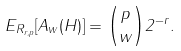<formula> <loc_0><loc_0><loc_500><loc_500>E _ { R _ { r , p } } [ A _ { w } ( H ) ] = { p \choose w } 2 ^ { - r } .</formula> 